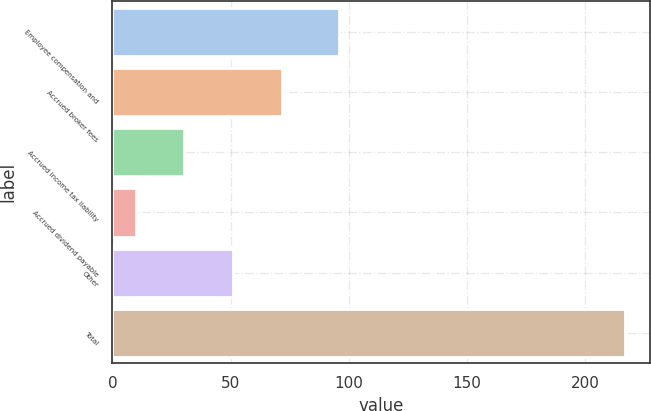Convert chart. <chart><loc_0><loc_0><loc_500><loc_500><bar_chart><fcel>Employee compensation and<fcel>Accrued broker fees<fcel>Accrued income tax liability<fcel>Accrued dividend payable<fcel>Other<fcel>Total<nl><fcel>95.8<fcel>71.87<fcel>30.49<fcel>9.8<fcel>51.18<fcel>216.7<nl></chart> 